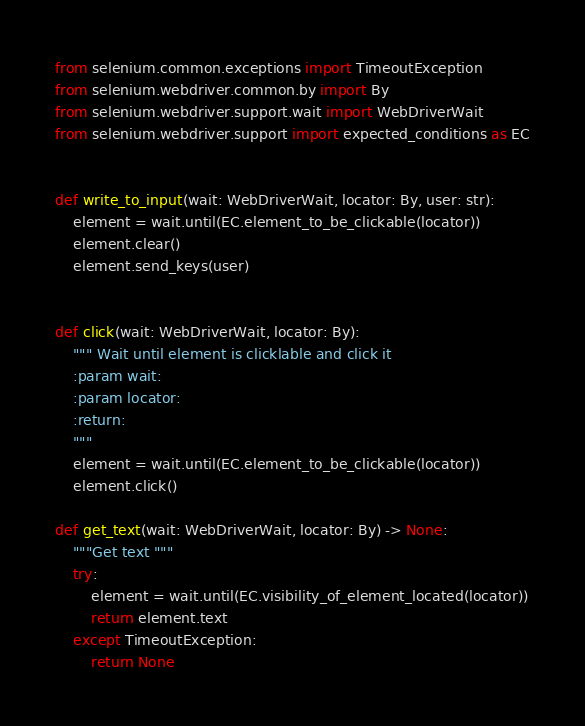<code> <loc_0><loc_0><loc_500><loc_500><_Python_>from selenium.common.exceptions import TimeoutException
from selenium.webdriver.common.by import By
from selenium.webdriver.support.wait import WebDriverWait
from selenium.webdriver.support import expected_conditions as EC


def write_to_input(wait: WebDriverWait, locator: By, user: str):
    element = wait.until(EC.element_to_be_clickable(locator))
    element.clear()
    element.send_keys(user)


def click(wait: WebDriverWait, locator: By):
    """ Wait until element is clicklable and click it
    :param wait:
    :param locator:
    :return:
    """
    element = wait.until(EC.element_to_be_clickable(locator))
    element.click()

def get_text(wait: WebDriverWait, locator: By) -> None:
    """Get text """
    try:
        element = wait.until(EC.visibility_of_element_located(locator))
        return element.text
    except TimeoutException:
        return None</code> 